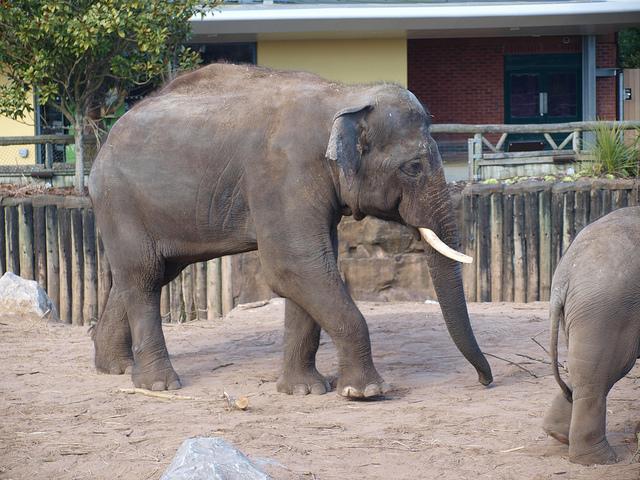Is this in a zoo?
Keep it brief. Yes. Do the elephants live on a farm?
Give a very brief answer. No. What is this animal?
Quick response, please. Elephant. What color is the building in the background?
Write a very short answer. Yellow. 